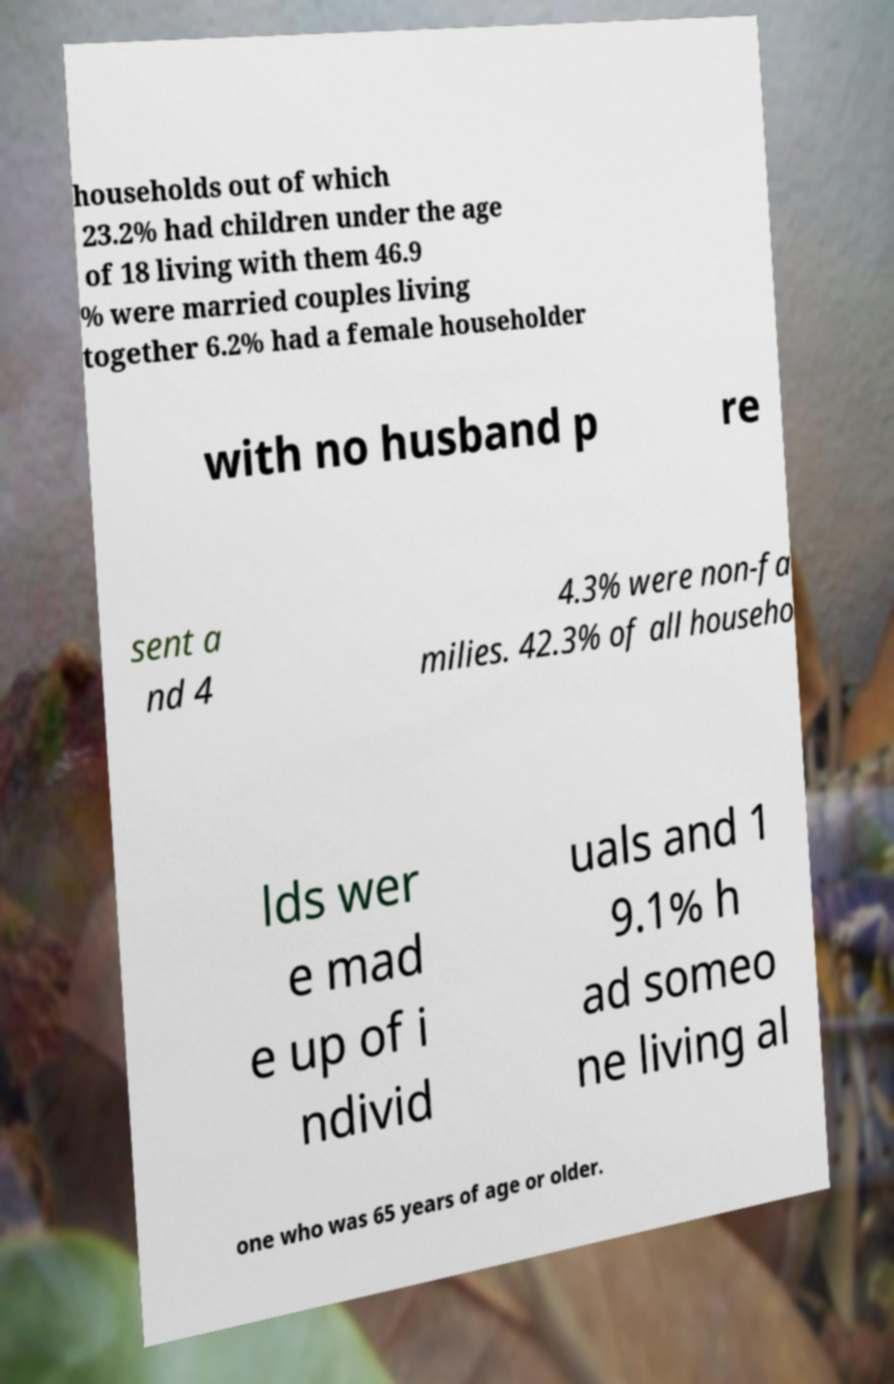Please identify and transcribe the text found in this image. households out of which 23.2% had children under the age of 18 living with them 46.9 % were married couples living together 6.2% had a female householder with no husband p re sent a nd 4 4.3% were non-fa milies. 42.3% of all househo lds wer e mad e up of i ndivid uals and 1 9.1% h ad someo ne living al one who was 65 years of age or older. 